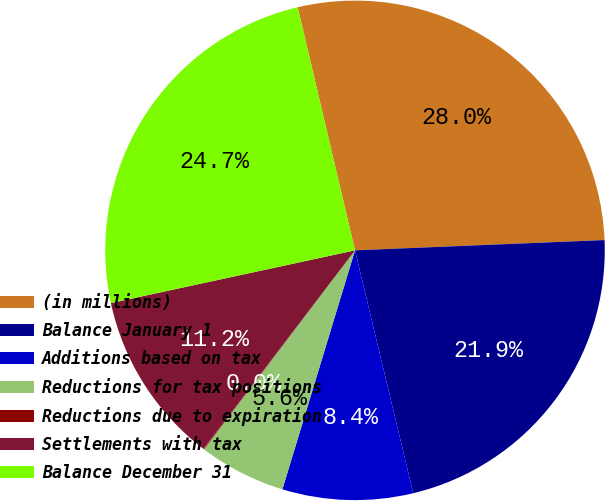<chart> <loc_0><loc_0><loc_500><loc_500><pie_chart><fcel>(in millions)<fcel>Balance January 1<fcel>Additions based on tax<fcel>Reductions for tax positions<fcel>Reductions due to expiration<fcel>Settlements with tax<fcel>Balance December 31<nl><fcel>28.03%<fcel>21.91%<fcel>8.44%<fcel>5.64%<fcel>0.04%<fcel>11.24%<fcel>24.7%<nl></chart> 